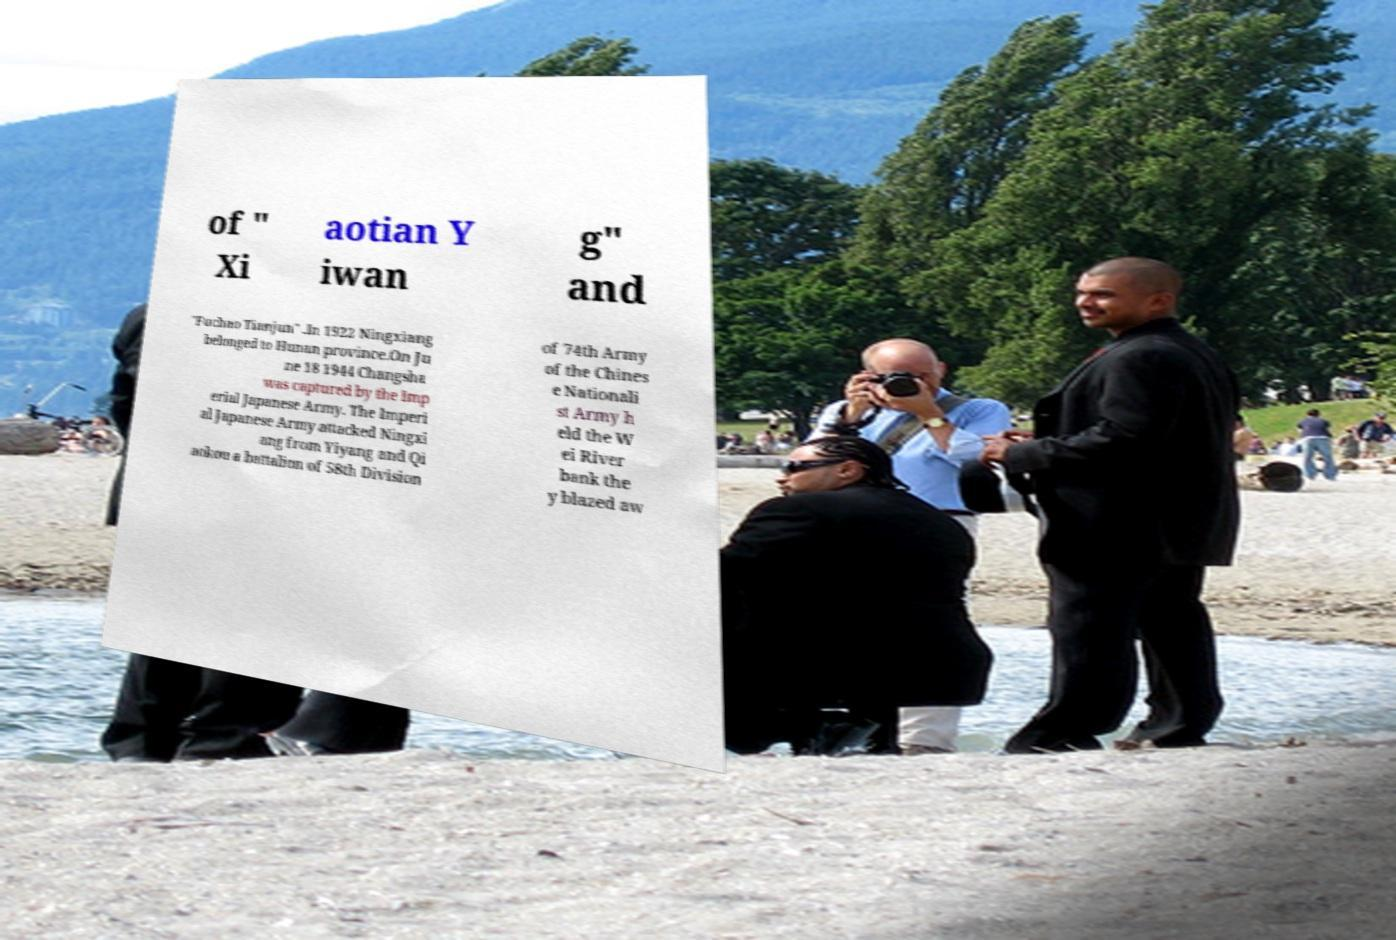Can you read and provide the text displayed in the image?This photo seems to have some interesting text. Can you extract and type it out for me? of " Xi aotian Y iwan g" and "Fuchao Tianjun" .In 1922 Ningxiang belonged to Hunan province.On Ju ne 18 1944 Changsha was captured by the Imp erial Japanese Army. The Imperi al Japanese Army attacked Ningxi ang from Yiyang and Qi aokou a battalion of 58th Division of 74th Army of the Chines e Nationali st Army h eld the W ei River bank the y blazed aw 